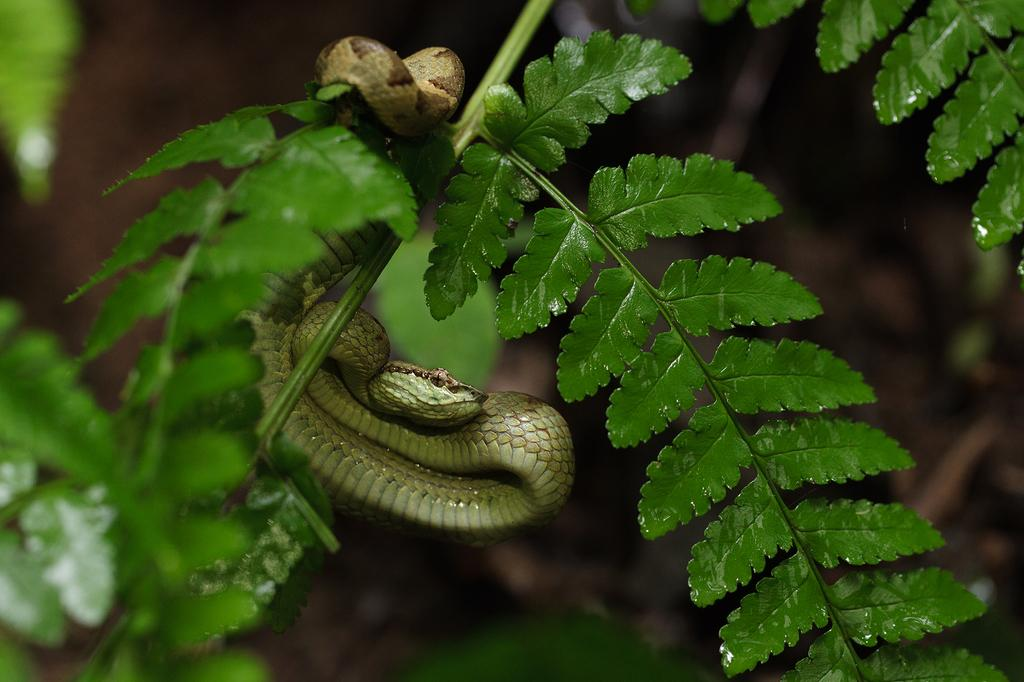What is the main subject of the image? The main subject of the image is a stem with leaves. Are there any other living creatures in the image besides the leaves? Yes, there is a snake in the image. Can you describe the background of the image? The background of the image is blurred. What type of farm animals can be seen in the image? There are no farm animals present in the image. What level of difficulty is the image designed for? The image does not have a level of difficulty, as it is a still image and not a game or challenge. 